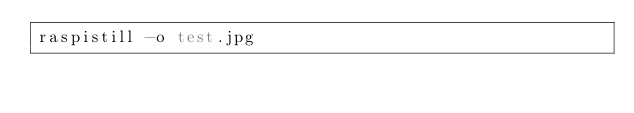Convert code to text. <code><loc_0><loc_0><loc_500><loc_500><_Bash_>raspistill -o test.jpg
</code> 